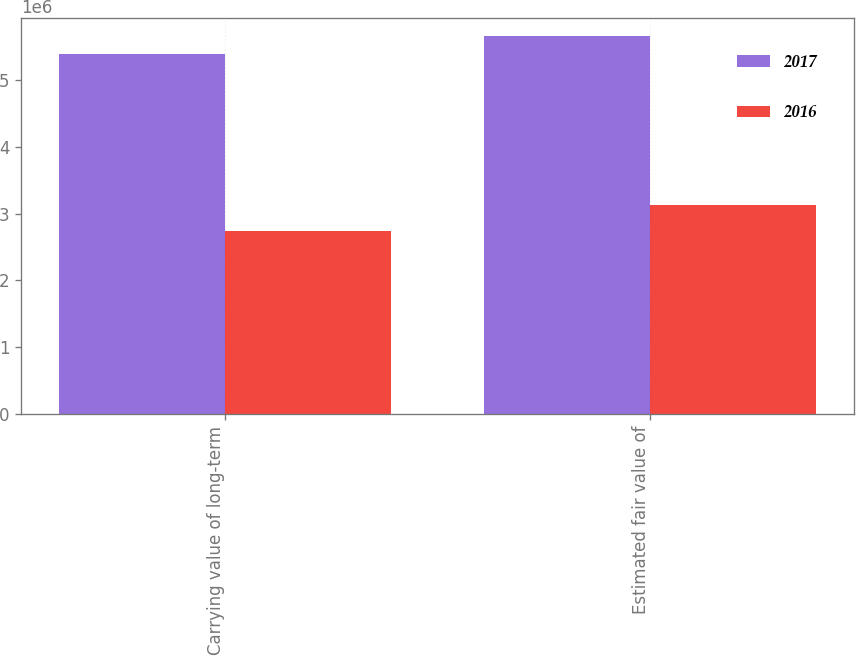Convert chart. <chart><loc_0><loc_0><loc_500><loc_500><stacked_bar_chart><ecel><fcel>Carrying value of long-term<fcel>Estimated fair value of<nl><fcel>2017<fcel>5.38334e+06<fcel>5.64553e+06<nl><fcel>2016<fcel>2.73314e+06<fcel>3.13399e+06<nl></chart> 